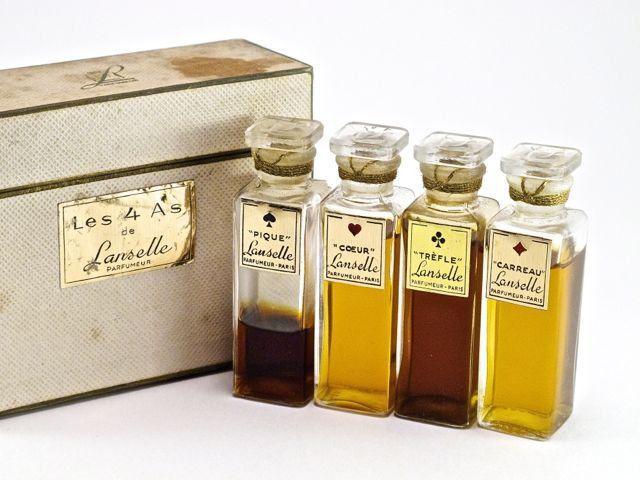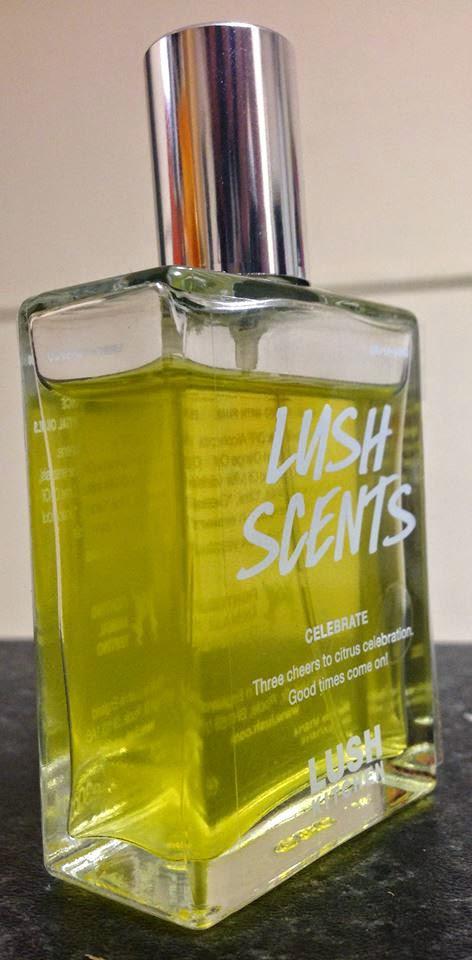The first image is the image on the left, the second image is the image on the right. Examine the images to the left and right. Is the description "There are at least four bottles of perfume." accurate? Answer yes or no. Yes. The first image is the image on the left, the second image is the image on the right. Evaluate the accuracy of this statement regarding the images: "There are at least five bottles of perfume.". Is it true? Answer yes or no. Yes. 